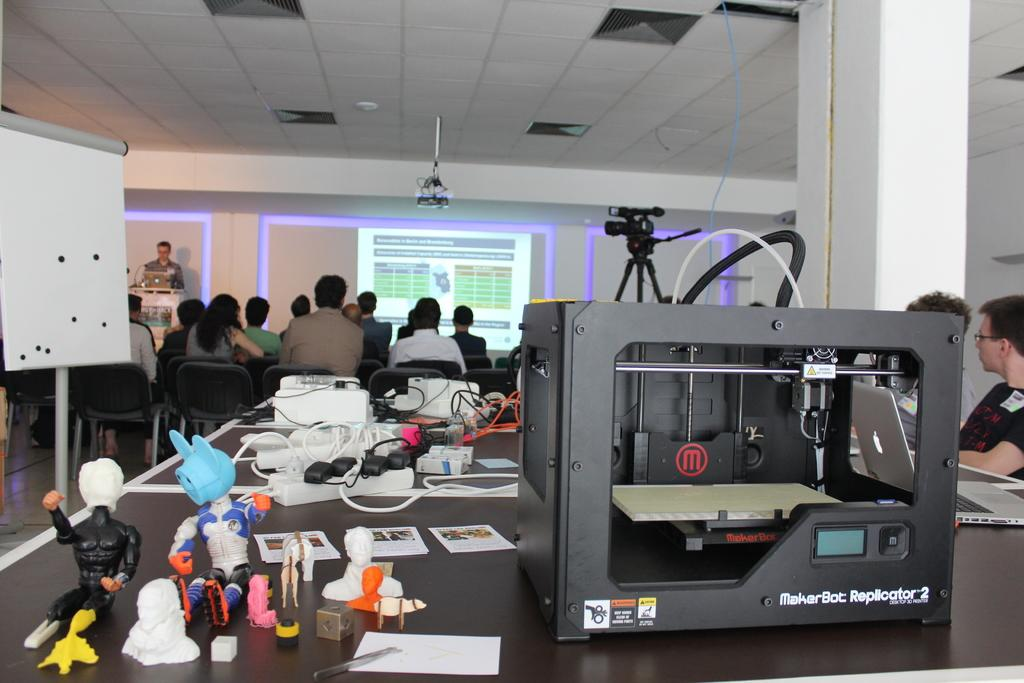<image>
Summarize the visual content of the image. A MakerBot Replicator desktop 3D printer sits on a table behind a group of people listening to the man behind the podium lecture. 